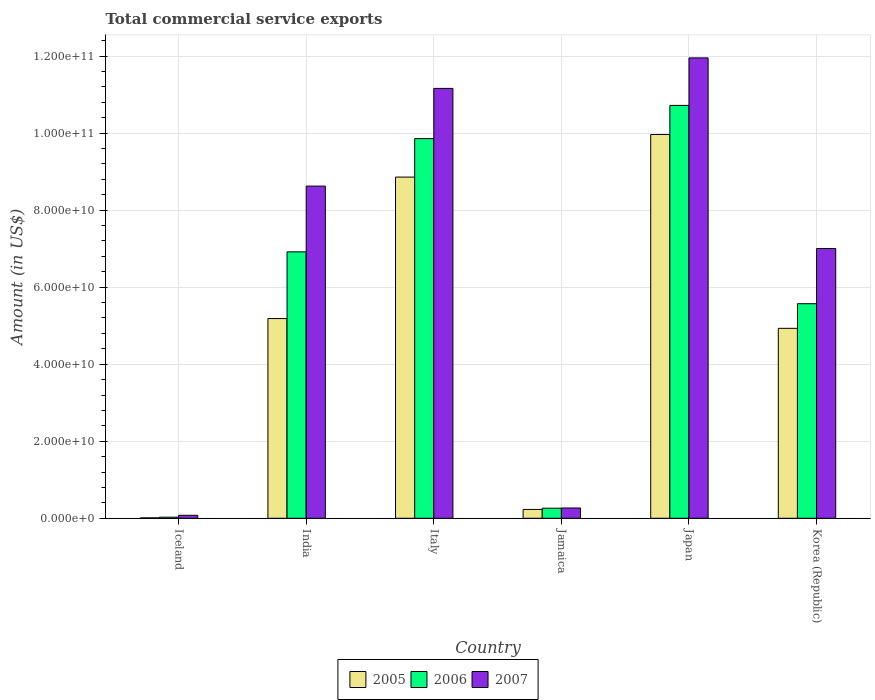How many different coloured bars are there?
Ensure brevity in your answer.  3. How many groups of bars are there?
Your response must be concise. 6. Are the number of bars per tick equal to the number of legend labels?
Your response must be concise. Yes. How many bars are there on the 2nd tick from the right?
Offer a very short reply. 3. In how many cases, is the number of bars for a given country not equal to the number of legend labels?
Ensure brevity in your answer.  0. What is the total commercial service exports in 2006 in Iceland?
Give a very brief answer. 2.80e+08. Across all countries, what is the maximum total commercial service exports in 2007?
Offer a terse response. 1.20e+11. Across all countries, what is the minimum total commercial service exports in 2006?
Your response must be concise. 2.80e+08. In which country was the total commercial service exports in 2006 minimum?
Make the answer very short. Iceland. What is the total total commercial service exports in 2007 in the graph?
Your answer should be very brief. 3.91e+11. What is the difference between the total commercial service exports in 2007 in Iceland and that in Italy?
Provide a short and direct response. -1.11e+11. What is the difference between the total commercial service exports in 2006 in Iceland and the total commercial service exports in 2005 in Italy?
Your answer should be compact. -8.83e+1. What is the average total commercial service exports in 2006 per country?
Your response must be concise. 5.56e+1. What is the difference between the total commercial service exports of/in 2006 and total commercial service exports of/in 2007 in Korea (Republic)?
Give a very brief answer. -1.43e+1. In how many countries, is the total commercial service exports in 2007 greater than 108000000000 US$?
Your answer should be very brief. 2. What is the ratio of the total commercial service exports in 2005 in India to that in Jamaica?
Make the answer very short. 22.59. What is the difference between the highest and the second highest total commercial service exports in 2005?
Keep it short and to the point. 4.78e+1. What is the difference between the highest and the lowest total commercial service exports in 2005?
Provide a short and direct response. 9.95e+1. In how many countries, is the total commercial service exports in 2006 greater than the average total commercial service exports in 2006 taken over all countries?
Your answer should be very brief. 4. Is the sum of the total commercial service exports in 2006 in Italy and Japan greater than the maximum total commercial service exports in 2005 across all countries?
Offer a very short reply. Yes. What does the 1st bar from the right in India represents?
Offer a very short reply. 2007. Is it the case that in every country, the sum of the total commercial service exports in 2006 and total commercial service exports in 2005 is greater than the total commercial service exports in 2007?
Provide a short and direct response. No. How many countries are there in the graph?
Provide a short and direct response. 6. What is the difference between two consecutive major ticks on the Y-axis?
Provide a succinct answer. 2.00e+1. Where does the legend appear in the graph?
Your answer should be very brief. Bottom center. How many legend labels are there?
Provide a short and direct response. 3. How are the legend labels stacked?
Offer a very short reply. Horizontal. What is the title of the graph?
Provide a short and direct response. Total commercial service exports. What is the label or title of the Y-axis?
Your answer should be compact. Amount (in US$). What is the Amount (in US$) of 2005 in Iceland?
Offer a very short reply. 1.06e+08. What is the Amount (in US$) of 2006 in Iceland?
Give a very brief answer. 2.80e+08. What is the Amount (in US$) of 2007 in Iceland?
Offer a very short reply. 7.74e+08. What is the Amount (in US$) of 2005 in India?
Provide a succinct answer. 5.19e+1. What is the Amount (in US$) in 2006 in India?
Your answer should be very brief. 6.92e+1. What is the Amount (in US$) in 2007 in India?
Offer a very short reply. 8.62e+1. What is the Amount (in US$) in 2005 in Italy?
Ensure brevity in your answer.  8.86e+1. What is the Amount (in US$) of 2006 in Italy?
Give a very brief answer. 9.86e+1. What is the Amount (in US$) of 2007 in Italy?
Your answer should be compact. 1.12e+11. What is the Amount (in US$) of 2005 in Jamaica?
Your response must be concise. 2.30e+09. What is the Amount (in US$) of 2006 in Jamaica?
Your response must be concise. 2.61e+09. What is the Amount (in US$) of 2007 in Jamaica?
Your answer should be compact. 2.67e+09. What is the Amount (in US$) of 2005 in Japan?
Give a very brief answer. 9.96e+1. What is the Amount (in US$) of 2006 in Japan?
Provide a short and direct response. 1.07e+11. What is the Amount (in US$) in 2007 in Japan?
Ensure brevity in your answer.  1.20e+11. What is the Amount (in US$) in 2005 in Korea (Republic)?
Provide a succinct answer. 4.93e+1. What is the Amount (in US$) of 2006 in Korea (Republic)?
Make the answer very short. 5.57e+1. What is the Amount (in US$) of 2007 in Korea (Republic)?
Your answer should be very brief. 7.00e+1. Across all countries, what is the maximum Amount (in US$) of 2005?
Offer a very short reply. 9.96e+1. Across all countries, what is the maximum Amount (in US$) of 2006?
Your answer should be very brief. 1.07e+11. Across all countries, what is the maximum Amount (in US$) in 2007?
Keep it short and to the point. 1.20e+11. Across all countries, what is the minimum Amount (in US$) in 2005?
Ensure brevity in your answer.  1.06e+08. Across all countries, what is the minimum Amount (in US$) in 2006?
Make the answer very short. 2.80e+08. Across all countries, what is the minimum Amount (in US$) in 2007?
Keep it short and to the point. 7.74e+08. What is the total Amount (in US$) of 2005 in the graph?
Offer a terse response. 2.92e+11. What is the total Amount (in US$) of 2006 in the graph?
Ensure brevity in your answer.  3.34e+11. What is the total Amount (in US$) in 2007 in the graph?
Your answer should be compact. 3.91e+11. What is the difference between the Amount (in US$) of 2005 in Iceland and that in India?
Provide a succinct answer. -5.17e+1. What is the difference between the Amount (in US$) of 2006 in Iceland and that in India?
Your answer should be compact. -6.89e+1. What is the difference between the Amount (in US$) in 2007 in Iceland and that in India?
Keep it short and to the point. -8.55e+1. What is the difference between the Amount (in US$) of 2005 in Iceland and that in Italy?
Ensure brevity in your answer.  -8.85e+1. What is the difference between the Amount (in US$) of 2006 in Iceland and that in Italy?
Your answer should be very brief. -9.83e+1. What is the difference between the Amount (in US$) in 2007 in Iceland and that in Italy?
Your answer should be compact. -1.11e+11. What is the difference between the Amount (in US$) of 2005 in Iceland and that in Jamaica?
Provide a short and direct response. -2.19e+09. What is the difference between the Amount (in US$) of 2006 in Iceland and that in Jamaica?
Your answer should be very brief. -2.33e+09. What is the difference between the Amount (in US$) of 2007 in Iceland and that in Jamaica?
Offer a terse response. -1.90e+09. What is the difference between the Amount (in US$) in 2005 in Iceland and that in Japan?
Provide a succinct answer. -9.95e+1. What is the difference between the Amount (in US$) in 2006 in Iceland and that in Japan?
Your answer should be compact. -1.07e+11. What is the difference between the Amount (in US$) of 2007 in Iceland and that in Japan?
Keep it short and to the point. -1.19e+11. What is the difference between the Amount (in US$) in 2005 in Iceland and that in Korea (Republic)?
Provide a short and direct response. -4.92e+1. What is the difference between the Amount (in US$) of 2006 in Iceland and that in Korea (Republic)?
Your response must be concise. -5.54e+1. What is the difference between the Amount (in US$) in 2007 in Iceland and that in Korea (Republic)?
Offer a terse response. -6.93e+1. What is the difference between the Amount (in US$) of 2005 in India and that in Italy?
Ensure brevity in your answer.  -3.67e+1. What is the difference between the Amount (in US$) in 2006 in India and that in Italy?
Keep it short and to the point. -2.94e+1. What is the difference between the Amount (in US$) of 2007 in India and that in Italy?
Your answer should be compact. -2.54e+1. What is the difference between the Amount (in US$) in 2005 in India and that in Jamaica?
Keep it short and to the point. 4.96e+1. What is the difference between the Amount (in US$) of 2006 in India and that in Jamaica?
Offer a terse response. 6.66e+1. What is the difference between the Amount (in US$) in 2007 in India and that in Jamaica?
Provide a short and direct response. 8.36e+1. What is the difference between the Amount (in US$) of 2005 in India and that in Japan?
Offer a very short reply. -4.78e+1. What is the difference between the Amount (in US$) of 2006 in India and that in Japan?
Ensure brevity in your answer.  -3.80e+1. What is the difference between the Amount (in US$) in 2007 in India and that in Japan?
Provide a short and direct response. -3.33e+1. What is the difference between the Amount (in US$) of 2005 in India and that in Korea (Republic)?
Offer a very short reply. 2.54e+09. What is the difference between the Amount (in US$) in 2006 in India and that in Korea (Republic)?
Your response must be concise. 1.35e+1. What is the difference between the Amount (in US$) of 2007 in India and that in Korea (Republic)?
Keep it short and to the point. 1.62e+1. What is the difference between the Amount (in US$) of 2005 in Italy and that in Jamaica?
Provide a short and direct response. 8.63e+1. What is the difference between the Amount (in US$) of 2006 in Italy and that in Jamaica?
Your response must be concise. 9.59e+1. What is the difference between the Amount (in US$) in 2007 in Italy and that in Jamaica?
Keep it short and to the point. 1.09e+11. What is the difference between the Amount (in US$) of 2005 in Italy and that in Japan?
Your answer should be very brief. -1.10e+1. What is the difference between the Amount (in US$) in 2006 in Italy and that in Japan?
Provide a short and direct response. -8.63e+09. What is the difference between the Amount (in US$) of 2007 in Italy and that in Japan?
Your response must be concise. -7.92e+09. What is the difference between the Amount (in US$) in 2005 in Italy and that in Korea (Republic)?
Provide a short and direct response. 3.93e+1. What is the difference between the Amount (in US$) in 2006 in Italy and that in Korea (Republic)?
Offer a very short reply. 4.29e+1. What is the difference between the Amount (in US$) in 2007 in Italy and that in Korea (Republic)?
Provide a short and direct response. 4.16e+1. What is the difference between the Amount (in US$) of 2005 in Jamaica and that in Japan?
Offer a very short reply. -9.73e+1. What is the difference between the Amount (in US$) of 2006 in Jamaica and that in Japan?
Offer a terse response. -1.05e+11. What is the difference between the Amount (in US$) in 2007 in Jamaica and that in Japan?
Keep it short and to the point. -1.17e+11. What is the difference between the Amount (in US$) of 2005 in Jamaica and that in Korea (Republic)?
Keep it short and to the point. -4.70e+1. What is the difference between the Amount (in US$) in 2006 in Jamaica and that in Korea (Republic)?
Your response must be concise. -5.31e+1. What is the difference between the Amount (in US$) in 2007 in Jamaica and that in Korea (Republic)?
Give a very brief answer. -6.74e+1. What is the difference between the Amount (in US$) of 2005 in Japan and that in Korea (Republic)?
Give a very brief answer. 5.03e+1. What is the difference between the Amount (in US$) in 2006 in Japan and that in Korea (Republic)?
Give a very brief answer. 5.15e+1. What is the difference between the Amount (in US$) of 2007 in Japan and that in Korea (Republic)?
Your answer should be compact. 4.95e+1. What is the difference between the Amount (in US$) of 2005 in Iceland and the Amount (in US$) of 2006 in India?
Offer a terse response. -6.91e+1. What is the difference between the Amount (in US$) in 2005 in Iceland and the Amount (in US$) in 2007 in India?
Ensure brevity in your answer.  -8.61e+1. What is the difference between the Amount (in US$) of 2006 in Iceland and the Amount (in US$) of 2007 in India?
Make the answer very short. -8.60e+1. What is the difference between the Amount (in US$) in 2005 in Iceland and the Amount (in US$) in 2006 in Italy?
Offer a very short reply. -9.85e+1. What is the difference between the Amount (in US$) in 2005 in Iceland and the Amount (in US$) in 2007 in Italy?
Your answer should be very brief. -1.11e+11. What is the difference between the Amount (in US$) of 2006 in Iceland and the Amount (in US$) of 2007 in Italy?
Offer a terse response. -1.11e+11. What is the difference between the Amount (in US$) in 2005 in Iceland and the Amount (in US$) in 2006 in Jamaica?
Give a very brief answer. -2.51e+09. What is the difference between the Amount (in US$) of 2005 in Iceland and the Amount (in US$) of 2007 in Jamaica?
Offer a very short reply. -2.56e+09. What is the difference between the Amount (in US$) of 2006 in Iceland and the Amount (in US$) of 2007 in Jamaica?
Your response must be concise. -2.39e+09. What is the difference between the Amount (in US$) of 2005 in Iceland and the Amount (in US$) of 2006 in Japan?
Offer a terse response. -1.07e+11. What is the difference between the Amount (in US$) of 2005 in Iceland and the Amount (in US$) of 2007 in Japan?
Give a very brief answer. -1.19e+11. What is the difference between the Amount (in US$) of 2006 in Iceland and the Amount (in US$) of 2007 in Japan?
Your answer should be compact. -1.19e+11. What is the difference between the Amount (in US$) in 2005 in Iceland and the Amount (in US$) in 2006 in Korea (Republic)?
Your answer should be compact. -5.56e+1. What is the difference between the Amount (in US$) in 2005 in Iceland and the Amount (in US$) in 2007 in Korea (Republic)?
Ensure brevity in your answer.  -6.99e+1. What is the difference between the Amount (in US$) of 2006 in Iceland and the Amount (in US$) of 2007 in Korea (Republic)?
Provide a succinct answer. -6.98e+1. What is the difference between the Amount (in US$) in 2005 in India and the Amount (in US$) in 2006 in Italy?
Offer a terse response. -4.67e+1. What is the difference between the Amount (in US$) in 2005 in India and the Amount (in US$) in 2007 in Italy?
Give a very brief answer. -5.98e+1. What is the difference between the Amount (in US$) in 2006 in India and the Amount (in US$) in 2007 in Italy?
Your answer should be very brief. -4.24e+1. What is the difference between the Amount (in US$) in 2005 in India and the Amount (in US$) in 2006 in Jamaica?
Ensure brevity in your answer.  4.92e+1. What is the difference between the Amount (in US$) of 2005 in India and the Amount (in US$) of 2007 in Jamaica?
Your response must be concise. 4.92e+1. What is the difference between the Amount (in US$) of 2006 in India and the Amount (in US$) of 2007 in Jamaica?
Your answer should be compact. 6.65e+1. What is the difference between the Amount (in US$) of 2005 in India and the Amount (in US$) of 2006 in Japan?
Your answer should be compact. -5.53e+1. What is the difference between the Amount (in US$) in 2005 in India and the Amount (in US$) in 2007 in Japan?
Provide a short and direct response. -6.77e+1. What is the difference between the Amount (in US$) in 2006 in India and the Amount (in US$) in 2007 in Japan?
Make the answer very short. -5.04e+1. What is the difference between the Amount (in US$) in 2005 in India and the Amount (in US$) in 2006 in Korea (Republic)?
Ensure brevity in your answer.  -3.85e+09. What is the difference between the Amount (in US$) of 2005 in India and the Amount (in US$) of 2007 in Korea (Republic)?
Offer a very short reply. -1.82e+1. What is the difference between the Amount (in US$) in 2006 in India and the Amount (in US$) in 2007 in Korea (Republic)?
Your response must be concise. -8.65e+08. What is the difference between the Amount (in US$) in 2005 in Italy and the Amount (in US$) in 2006 in Jamaica?
Your answer should be very brief. 8.60e+1. What is the difference between the Amount (in US$) in 2005 in Italy and the Amount (in US$) in 2007 in Jamaica?
Keep it short and to the point. 8.59e+1. What is the difference between the Amount (in US$) of 2006 in Italy and the Amount (in US$) of 2007 in Jamaica?
Your answer should be compact. 9.59e+1. What is the difference between the Amount (in US$) in 2005 in Italy and the Amount (in US$) in 2006 in Japan?
Make the answer very short. -1.86e+1. What is the difference between the Amount (in US$) of 2005 in Italy and the Amount (in US$) of 2007 in Japan?
Your answer should be compact. -3.09e+1. What is the difference between the Amount (in US$) of 2006 in Italy and the Amount (in US$) of 2007 in Japan?
Provide a succinct answer. -2.10e+1. What is the difference between the Amount (in US$) in 2005 in Italy and the Amount (in US$) in 2006 in Korea (Republic)?
Offer a terse response. 3.29e+1. What is the difference between the Amount (in US$) of 2005 in Italy and the Amount (in US$) of 2007 in Korea (Republic)?
Give a very brief answer. 1.85e+1. What is the difference between the Amount (in US$) of 2006 in Italy and the Amount (in US$) of 2007 in Korea (Republic)?
Provide a short and direct response. 2.85e+1. What is the difference between the Amount (in US$) of 2005 in Jamaica and the Amount (in US$) of 2006 in Japan?
Your response must be concise. -1.05e+11. What is the difference between the Amount (in US$) of 2005 in Jamaica and the Amount (in US$) of 2007 in Japan?
Ensure brevity in your answer.  -1.17e+11. What is the difference between the Amount (in US$) of 2006 in Jamaica and the Amount (in US$) of 2007 in Japan?
Your answer should be very brief. -1.17e+11. What is the difference between the Amount (in US$) in 2005 in Jamaica and the Amount (in US$) in 2006 in Korea (Republic)?
Your response must be concise. -5.34e+1. What is the difference between the Amount (in US$) of 2005 in Jamaica and the Amount (in US$) of 2007 in Korea (Republic)?
Offer a very short reply. -6.77e+1. What is the difference between the Amount (in US$) in 2006 in Jamaica and the Amount (in US$) in 2007 in Korea (Republic)?
Provide a short and direct response. -6.74e+1. What is the difference between the Amount (in US$) in 2005 in Japan and the Amount (in US$) in 2006 in Korea (Republic)?
Provide a short and direct response. 4.39e+1. What is the difference between the Amount (in US$) of 2005 in Japan and the Amount (in US$) of 2007 in Korea (Republic)?
Give a very brief answer. 2.96e+1. What is the difference between the Amount (in US$) in 2006 in Japan and the Amount (in US$) in 2007 in Korea (Republic)?
Your answer should be very brief. 3.72e+1. What is the average Amount (in US$) of 2005 per country?
Make the answer very short. 4.86e+1. What is the average Amount (in US$) of 2006 per country?
Your answer should be compact. 5.56e+1. What is the average Amount (in US$) in 2007 per country?
Make the answer very short. 6.51e+1. What is the difference between the Amount (in US$) in 2005 and Amount (in US$) in 2006 in Iceland?
Your answer should be compact. -1.74e+08. What is the difference between the Amount (in US$) in 2005 and Amount (in US$) in 2007 in Iceland?
Give a very brief answer. -6.68e+08. What is the difference between the Amount (in US$) in 2006 and Amount (in US$) in 2007 in Iceland?
Keep it short and to the point. -4.94e+08. What is the difference between the Amount (in US$) of 2005 and Amount (in US$) of 2006 in India?
Ensure brevity in your answer.  -1.73e+1. What is the difference between the Amount (in US$) in 2005 and Amount (in US$) in 2007 in India?
Ensure brevity in your answer.  -3.44e+1. What is the difference between the Amount (in US$) in 2006 and Amount (in US$) in 2007 in India?
Ensure brevity in your answer.  -1.71e+1. What is the difference between the Amount (in US$) in 2005 and Amount (in US$) in 2006 in Italy?
Your answer should be very brief. -9.98e+09. What is the difference between the Amount (in US$) in 2005 and Amount (in US$) in 2007 in Italy?
Provide a succinct answer. -2.30e+1. What is the difference between the Amount (in US$) of 2006 and Amount (in US$) of 2007 in Italy?
Give a very brief answer. -1.30e+1. What is the difference between the Amount (in US$) of 2005 and Amount (in US$) of 2006 in Jamaica?
Provide a succinct answer. -3.18e+08. What is the difference between the Amount (in US$) in 2005 and Amount (in US$) in 2007 in Jamaica?
Make the answer very short. -3.74e+08. What is the difference between the Amount (in US$) in 2006 and Amount (in US$) in 2007 in Jamaica?
Ensure brevity in your answer.  -5.61e+07. What is the difference between the Amount (in US$) in 2005 and Amount (in US$) in 2006 in Japan?
Ensure brevity in your answer.  -7.56e+09. What is the difference between the Amount (in US$) of 2005 and Amount (in US$) of 2007 in Japan?
Ensure brevity in your answer.  -1.99e+1. What is the difference between the Amount (in US$) of 2006 and Amount (in US$) of 2007 in Japan?
Offer a very short reply. -1.23e+1. What is the difference between the Amount (in US$) in 2005 and Amount (in US$) in 2006 in Korea (Republic)?
Keep it short and to the point. -6.39e+09. What is the difference between the Amount (in US$) in 2005 and Amount (in US$) in 2007 in Korea (Republic)?
Your answer should be very brief. -2.07e+1. What is the difference between the Amount (in US$) of 2006 and Amount (in US$) of 2007 in Korea (Republic)?
Make the answer very short. -1.43e+1. What is the ratio of the Amount (in US$) of 2005 in Iceland to that in India?
Your response must be concise. 0. What is the ratio of the Amount (in US$) of 2006 in Iceland to that in India?
Your response must be concise. 0. What is the ratio of the Amount (in US$) of 2007 in Iceland to that in India?
Ensure brevity in your answer.  0.01. What is the ratio of the Amount (in US$) in 2005 in Iceland to that in Italy?
Give a very brief answer. 0. What is the ratio of the Amount (in US$) of 2006 in Iceland to that in Italy?
Your answer should be very brief. 0. What is the ratio of the Amount (in US$) in 2007 in Iceland to that in Italy?
Your answer should be compact. 0.01. What is the ratio of the Amount (in US$) of 2005 in Iceland to that in Jamaica?
Give a very brief answer. 0.05. What is the ratio of the Amount (in US$) in 2006 in Iceland to that in Jamaica?
Provide a short and direct response. 0.11. What is the ratio of the Amount (in US$) in 2007 in Iceland to that in Jamaica?
Your answer should be very brief. 0.29. What is the ratio of the Amount (in US$) of 2005 in Iceland to that in Japan?
Make the answer very short. 0. What is the ratio of the Amount (in US$) of 2006 in Iceland to that in Japan?
Offer a very short reply. 0. What is the ratio of the Amount (in US$) in 2007 in Iceland to that in Japan?
Keep it short and to the point. 0.01. What is the ratio of the Amount (in US$) in 2005 in Iceland to that in Korea (Republic)?
Offer a terse response. 0. What is the ratio of the Amount (in US$) of 2006 in Iceland to that in Korea (Republic)?
Make the answer very short. 0.01. What is the ratio of the Amount (in US$) of 2007 in Iceland to that in Korea (Republic)?
Give a very brief answer. 0.01. What is the ratio of the Amount (in US$) in 2005 in India to that in Italy?
Give a very brief answer. 0.59. What is the ratio of the Amount (in US$) in 2006 in India to that in Italy?
Offer a very short reply. 0.7. What is the ratio of the Amount (in US$) of 2007 in India to that in Italy?
Offer a terse response. 0.77. What is the ratio of the Amount (in US$) in 2005 in India to that in Jamaica?
Your response must be concise. 22.59. What is the ratio of the Amount (in US$) in 2006 in India to that in Jamaica?
Keep it short and to the point. 26.47. What is the ratio of the Amount (in US$) in 2007 in India to that in Jamaica?
Your answer should be compact. 32.3. What is the ratio of the Amount (in US$) of 2005 in India to that in Japan?
Offer a very short reply. 0.52. What is the ratio of the Amount (in US$) of 2006 in India to that in Japan?
Provide a short and direct response. 0.65. What is the ratio of the Amount (in US$) of 2007 in India to that in Japan?
Give a very brief answer. 0.72. What is the ratio of the Amount (in US$) of 2005 in India to that in Korea (Republic)?
Ensure brevity in your answer.  1.05. What is the ratio of the Amount (in US$) of 2006 in India to that in Korea (Republic)?
Give a very brief answer. 1.24. What is the ratio of the Amount (in US$) of 2007 in India to that in Korea (Republic)?
Ensure brevity in your answer.  1.23. What is the ratio of the Amount (in US$) of 2005 in Italy to that in Jamaica?
Ensure brevity in your answer.  38.59. What is the ratio of the Amount (in US$) of 2006 in Italy to that in Jamaica?
Your answer should be compact. 37.71. What is the ratio of the Amount (in US$) in 2007 in Italy to that in Jamaica?
Keep it short and to the point. 41.81. What is the ratio of the Amount (in US$) in 2005 in Italy to that in Japan?
Give a very brief answer. 0.89. What is the ratio of the Amount (in US$) in 2006 in Italy to that in Japan?
Provide a succinct answer. 0.92. What is the ratio of the Amount (in US$) of 2007 in Italy to that in Japan?
Give a very brief answer. 0.93. What is the ratio of the Amount (in US$) of 2005 in Italy to that in Korea (Republic)?
Make the answer very short. 1.8. What is the ratio of the Amount (in US$) in 2006 in Italy to that in Korea (Republic)?
Offer a very short reply. 1.77. What is the ratio of the Amount (in US$) in 2007 in Italy to that in Korea (Republic)?
Your answer should be compact. 1.59. What is the ratio of the Amount (in US$) of 2005 in Jamaica to that in Japan?
Keep it short and to the point. 0.02. What is the ratio of the Amount (in US$) in 2006 in Jamaica to that in Japan?
Your answer should be compact. 0.02. What is the ratio of the Amount (in US$) of 2007 in Jamaica to that in Japan?
Make the answer very short. 0.02. What is the ratio of the Amount (in US$) of 2005 in Jamaica to that in Korea (Republic)?
Provide a short and direct response. 0.05. What is the ratio of the Amount (in US$) in 2006 in Jamaica to that in Korea (Republic)?
Offer a terse response. 0.05. What is the ratio of the Amount (in US$) of 2007 in Jamaica to that in Korea (Republic)?
Your answer should be very brief. 0.04. What is the ratio of the Amount (in US$) in 2005 in Japan to that in Korea (Republic)?
Offer a terse response. 2.02. What is the ratio of the Amount (in US$) of 2006 in Japan to that in Korea (Republic)?
Provide a succinct answer. 1.92. What is the ratio of the Amount (in US$) in 2007 in Japan to that in Korea (Republic)?
Your answer should be compact. 1.71. What is the difference between the highest and the second highest Amount (in US$) in 2005?
Give a very brief answer. 1.10e+1. What is the difference between the highest and the second highest Amount (in US$) of 2006?
Your answer should be compact. 8.63e+09. What is the difference between the highest and the second highest Amount (in US$) of 2007?
Your response must be concise. 7.92e+09. What is the difference between the highest and the lowest Amount (in US$) of 2005?
Your response must be concise. 9.95e+1. What is the difference between the highest and the lowest Amount (in US$) in 2006?
Your answer should be compact. 1.07e+11. What is the difference between the highest and the lowest Amount (in US$) in 2007?
Provide a succinct answer. 1.19e+11. 